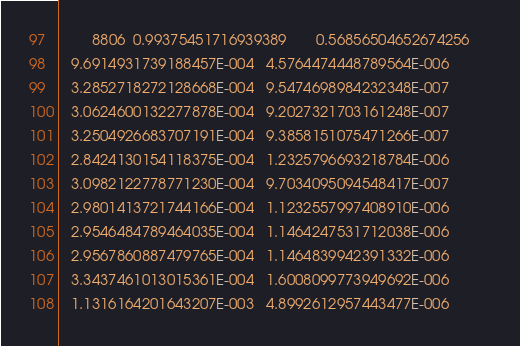Convert code to text. <code><loc_0><loc_0><loc_500><loc_500><_SML_>        8806  0.99375451716939389       0.56856504652674256     
   9.6914931739188457E-004   4.5764474448789564E-006
   3.2852718272128668E-004   9.5474698984232348E-007
   3.0624600132277878E-004   9.2027321703161248E-007
   3.2504926683707191E-004   9.3858151075471266E-007
   2.8424130154118375E-004   1.2325796693218784E-006
   3.0982122778771230E-004   9.7034095094548417E-007
   2.9801413721744166E-004   1.1232557997408910E-006
   2.9546484789464035E-004   1.1464247531712038E-006
   2.9567860887479765E-004   1.1464839942391332E-006
   3.3437461013015361E-004   1.6008099773949692E-006
   1.1316164201643207E-003   4.8992612957443477E-006</code> 